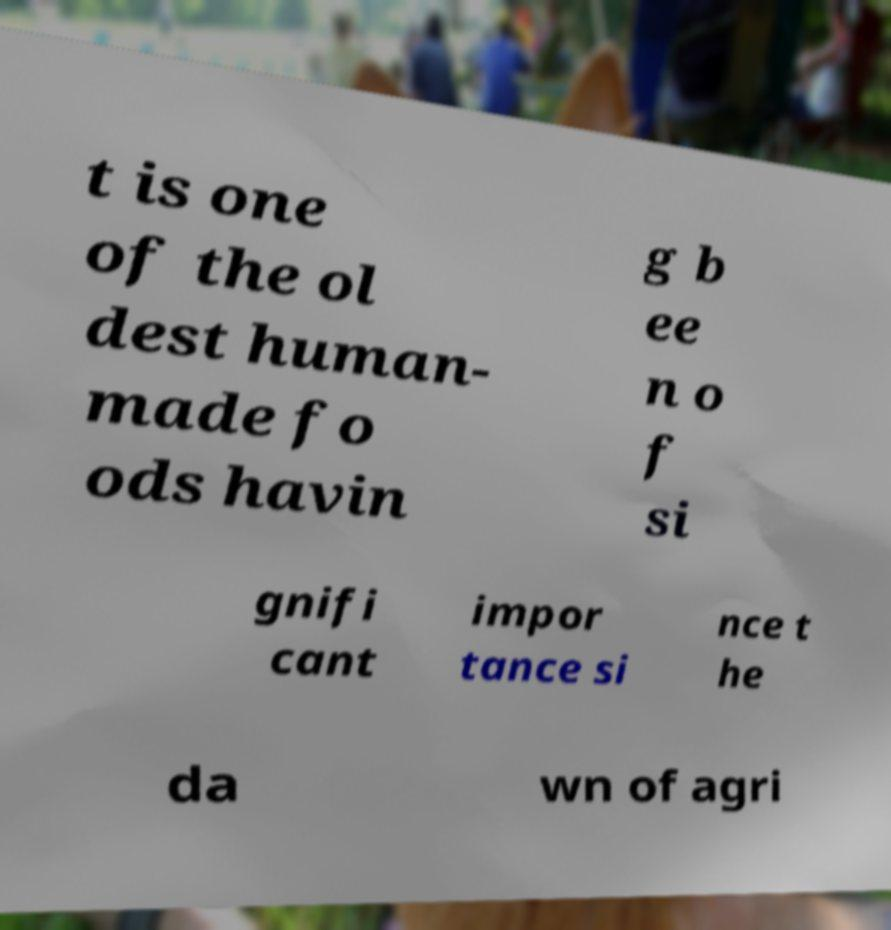Can you read and provide the text displayed in the image?This photo seems to have some interesting text. Can you extract and type it out for me? t is one of the ol dest human- made fo ods havin g b ee n o f si gnifi cant impor tance si nce t he da wn of agri 